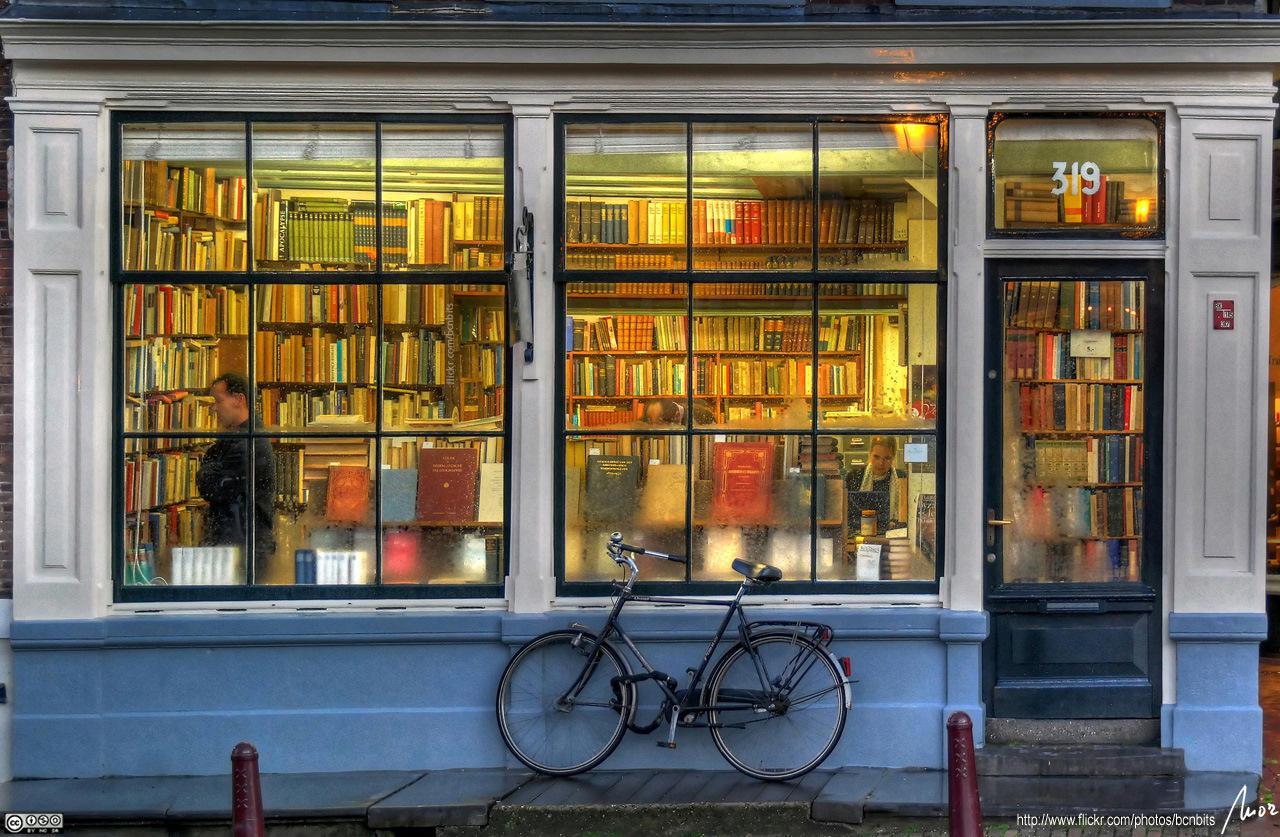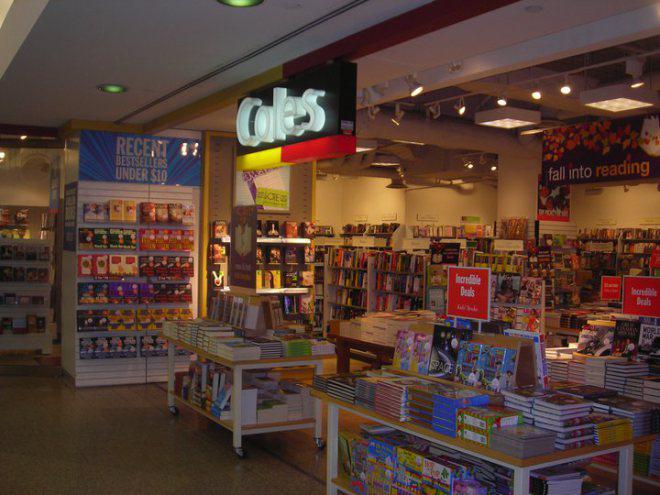The first image is the image on the left, the second image is the image on the right. Considering the images on both sides, is "one of the two images contains books in chromatic order; there appears to be a rainbow effect created with books." valid? Answer yes or no. No. The first image is the image on the left, the second image is the image on the right. Evaluate the accuracy of this statement regarding the images: "One image features a bookstore exterior showing a lighted interior, and something upright is outside in front of the store window.". Is it true? Answer yes or no. Yes. 